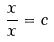<formula> <loc_0><loc_0><loc_500><loc_500>\frac { x } { x } = c</formula> 